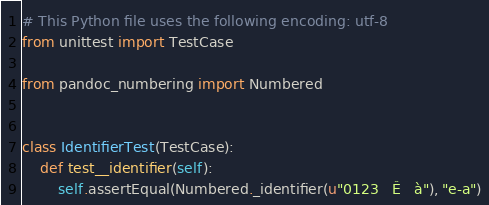<code> <loc_0><loc_0><loc_500><loc_500><_Python_># This Python file uses the following encoding: utf-8
from unittest import TestCase

from pandoc_numbering import Numbered


class IdentifierTest(TestCase):
    def test__identifier(self):
        self.assertEqual(Numbered._identifier(u"0123   Ê   à"), "e-a")
</code> 